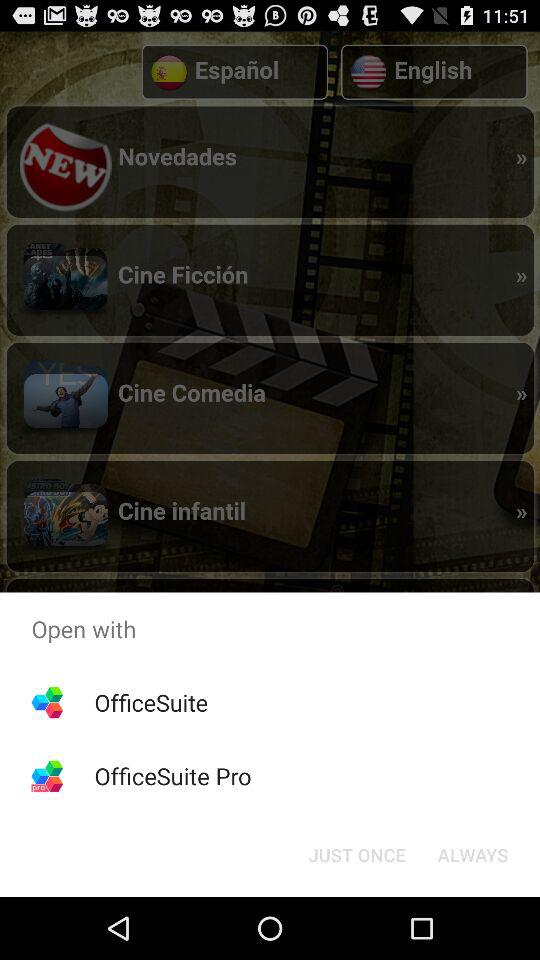What applications can be used to open it? The applications are "OfficeSuite" and "OfficeSuite Pro". 